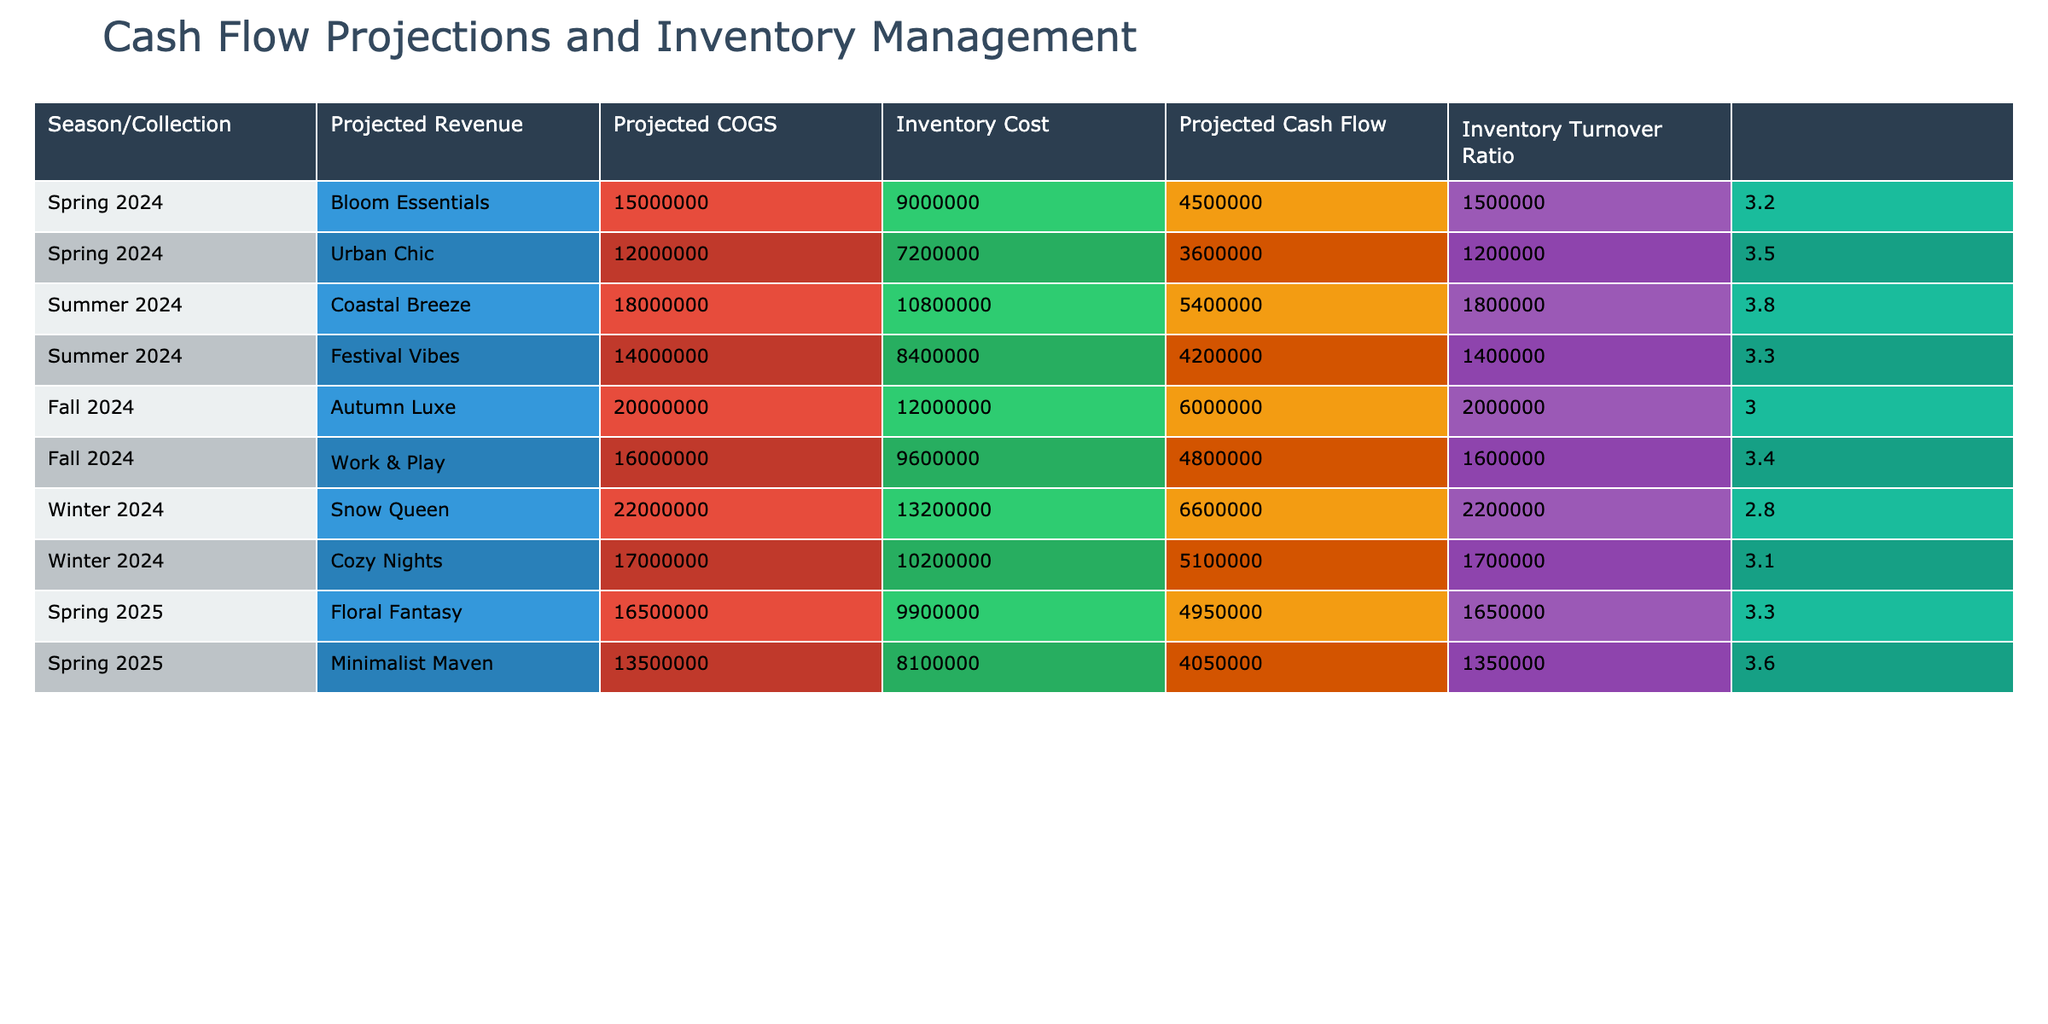What is the projected revenue for the Spring 2024 collection, Bloom Essentials? The table shows that the projected revenue for Bloom Essentials in Spring 2024 is listed directly under the Projected Revenue column. The value provided is 15,000,000.
Answer: 15,000,000 What is the inventory turnover ratio for the Summer 2024 collection, Coastal Breeze? The table provides the inventory turnover ratio for Coastal Breeze in the corresponding row, which is 3.8.
Answer: 3.8 Which collection has the highest projected cash flow in Winter 2024? Looking through the Winter 2024 rows, we find that Snow Queen shows a projected cash flow of 2,200,000, which is higher than Cozy Nights at 1,700,000.
Answer: Snow Queen What is the total projected revenue from the Fall 2024 collections? The projected revenues from the Fall 2024 collections are: Autumn Luxe (20,000,000) and Work & Play (16,000,000). Adding these gives 20,000,000 + 16,000,000 = 36,000,000.
Answer: 36,000,000 Is the projected COGS for the Spring 2025, Floral Fantasy higher than that of the Summer 2024, Coastal Breeze? The projected COGS for Floral Fantasy is 9,900,000, while for Coastal Breeze it is 10,800,000. Since 9,900,000 is less than 10,800,000, the answer is no.
Answer: No What is the average projected cash flow across all collections for Spring 2024? The projected cash flows for Spring 2024 are Bloom Essentials (1,500,000) and Urban Chic (1,200,000). The average is calculated as (1,500,000 + 1,200,000) / 2 = 1,350,000.
Answer: 1,350,000 Which collection has the lowest inventory cost in the Summer 2024 season? Comparing the inventory costs for Summer 2024: Coastal Breeze has 5,400,000 and Festival Vibes has 4,200,000. Festival Vibes has the lower inventory cost.
Answer: Festival Vibes If we combine the projected cash flow of both Winter 2024 collections, what is the total? The projected cash flows are: Snow Queen (2,200,000) and Cozy Nights (1,700,000). Summing these gives 2,200,000 + 1,700,000 = 3,900,000.
Answer: 3,900,000 Identify the collection with the highest inventory turnover ratio, and what is that ratio? Reviewing the inventory turnover ratios across all collections, Summer 2024’s Coastal Breeze at 3.8 has the highest ratio when compared to others.
Answer: Coastal Breeze, 3.8 Is the projected cash flow for Urban Chic higher than that of the collection, Autumn Luxe? The projected cash flow for Urban Chic is 1,200,000, whereas for Autumn Luxe it is 2,000,000. Thus, Urban Chic does not exceed Autumn Luxe.
Answer: No 